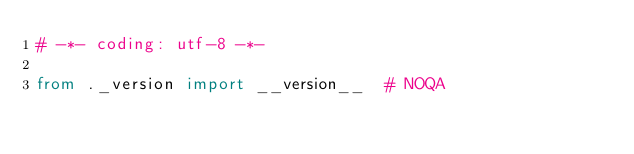Convert code to text. <code><loc_0><loc_0><loc_500><loc_500><_Python_># -*- coding: utf-8 -*-

from ._version import __version__  # NOQA
</code> 